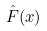Convert formula to latex. <formula><loc_0><loc_0><loc_500><loc_500>\hat { F } ( x )</formula> 